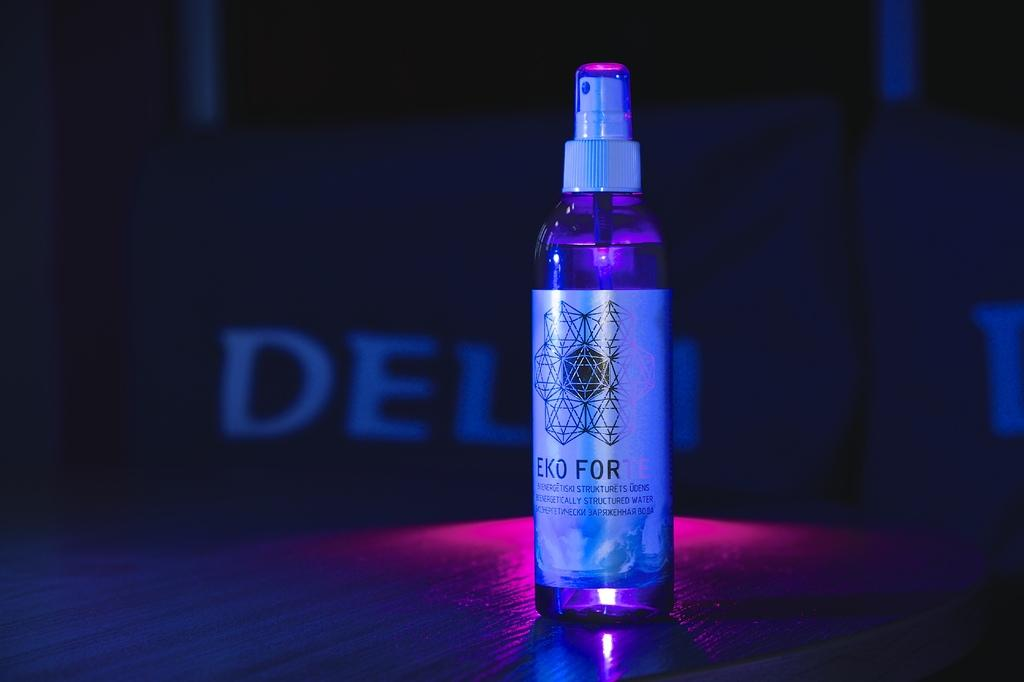<image>
Relay a brief, clear account of the picture shown. A spray bottle with the words EKO FOR on it 